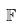<formula> <loc_0><loc_0><loc_500><loc_500>\mathbb { F }</formula> 